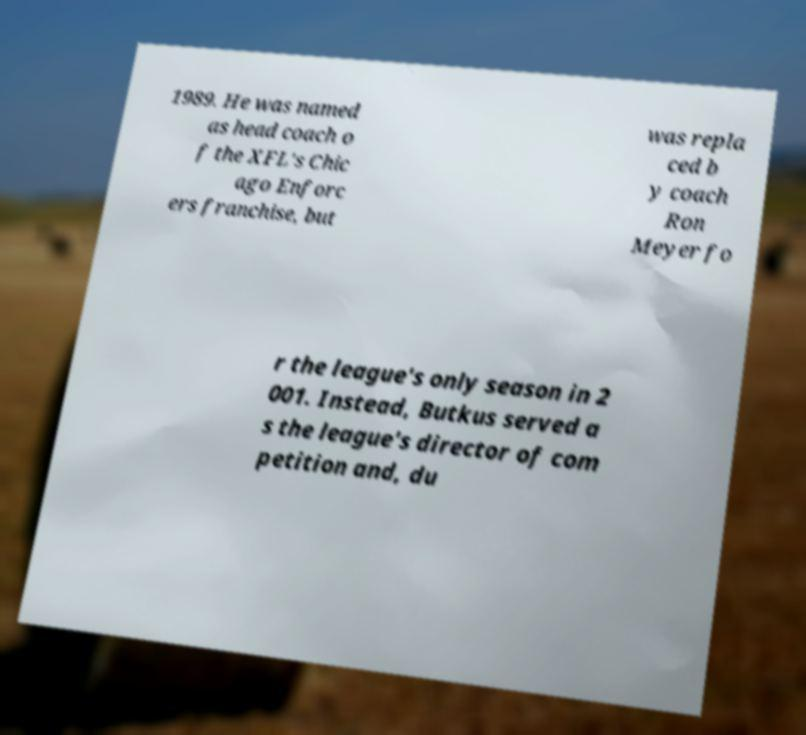What messages or text are displayed in this image? I need them in a readable, typed format. 1989. He was named as head coach o f the XFL's Chic ago Enforc ers franchise, but was repla ced b y coach Ron Meyer fo r the league's only season in 2 001. Instead, Butkus served a s the league's director of com petition and, du 